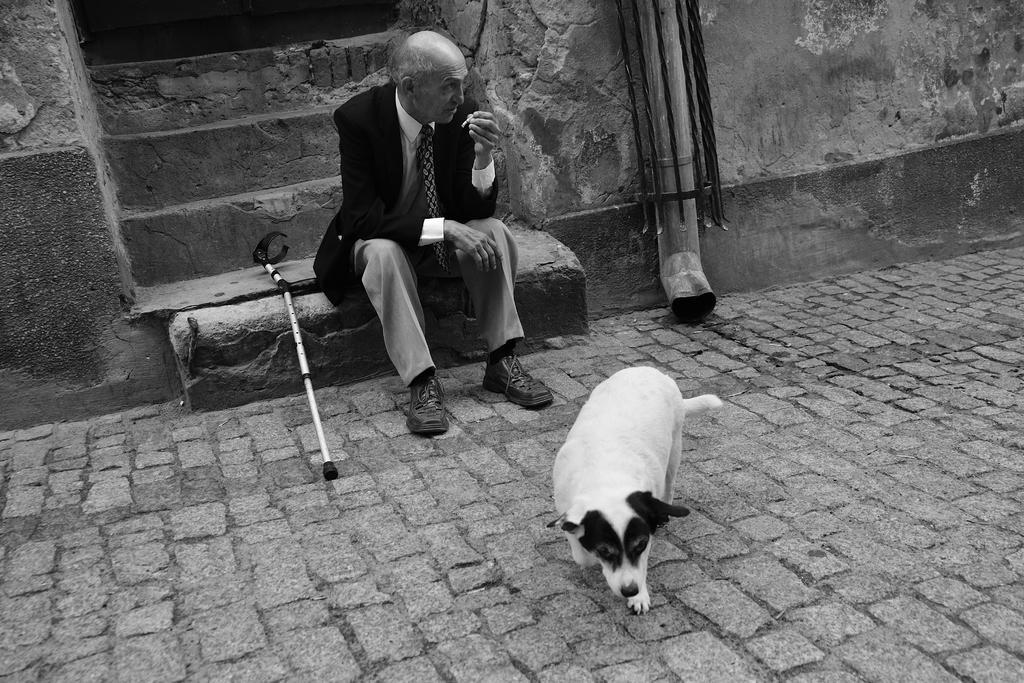Can you describe this image briefly? In this image I can see a person sitting on stairs, in front of the person I can see a dog. I can also see a stick beside the person and the image is in black and white. 